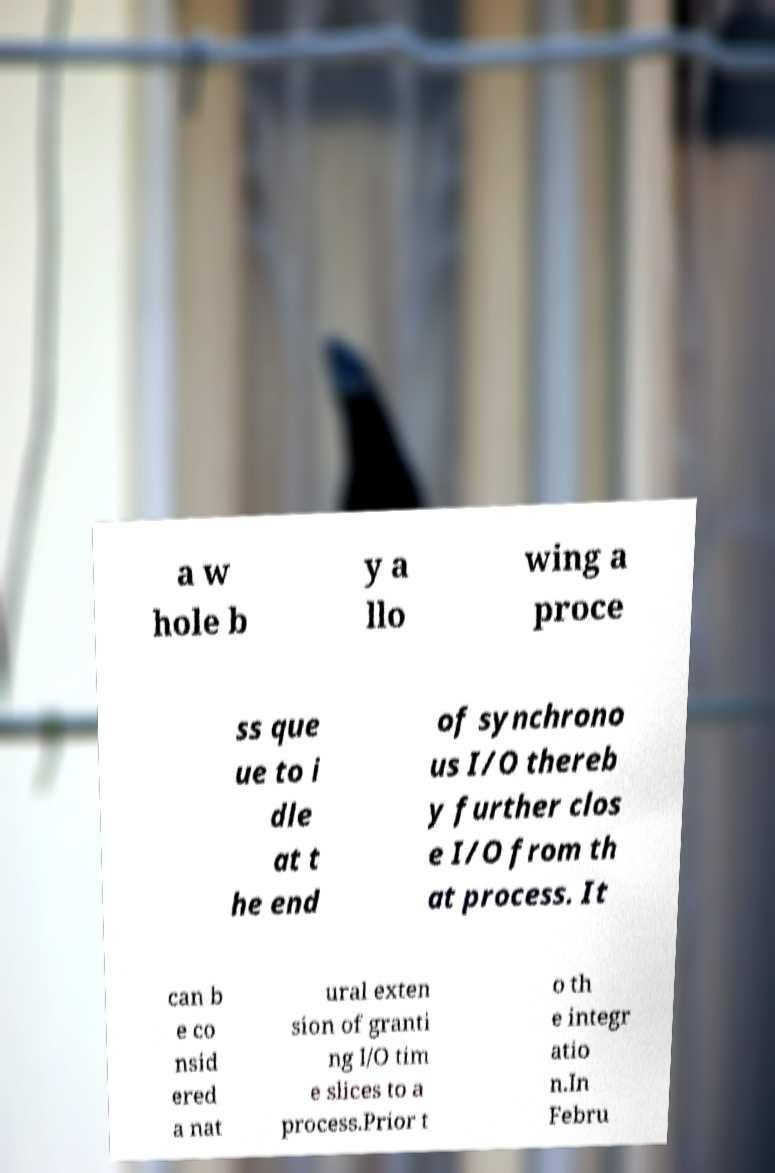There's text embedded in this image that I need extracted. Can you transcribe it verbatim? a w hole b y a llo wing a proce ss que ue to i dle at t he end of synchrono us I/O thereb y further clos e I/O from th at process. It can b e co nsid ered a nat ural exten sion of granti ng I/O tim e slices to a process.Prior t o th e integr atio n.In Febru 